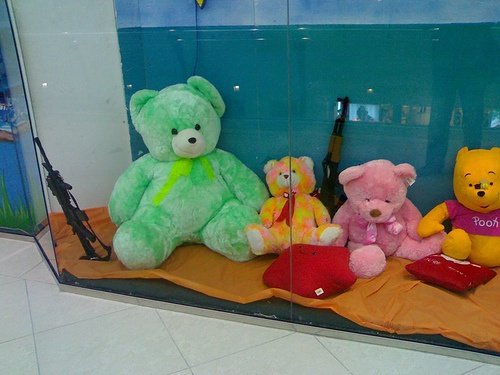Describe the objects in this image and their specific colors. I can see teddy bear in teal, green, turquoise, and darkgray tones, teddy bear in teal, brown, lightpink, and salmon tones, teddy bear in teal, orange, olive, purple, and maroon tones, and teddy bear in teal, olive, salmon, and tan tones in this image. 